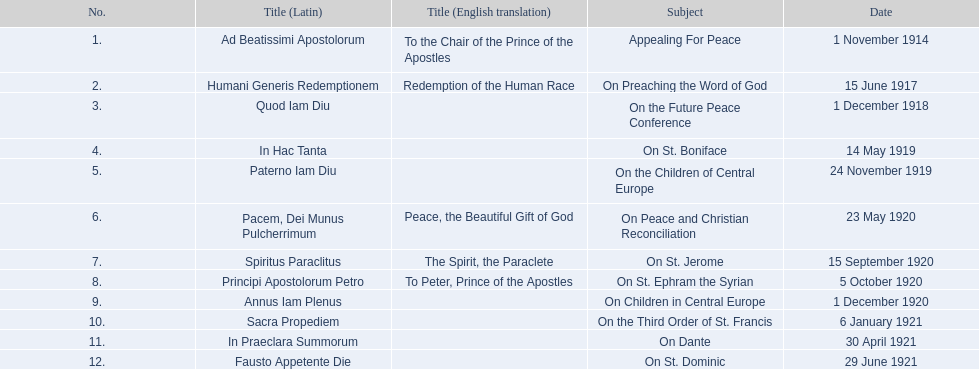Give me the full table as a dictionary. {'header': ['No.', 'Title (Latin)', 'Title (English translation)', 'Subject', 'Date'], 'rows': [['1.', 'Ad Beatissimi Apostolorum', 'To the Chair of the Prince of the Apostles', 'Appealing For Peace', '1 November 1914'], ['2.', 'Humani Generis Redemptionem', 'Redemption of the Human Race', 'On Preaching the Word of God', '15 June 1917'], ['3.', 'Quod Iam Diu', '', 'On the Future Peace Conference', '1 December 1918'], ['4.', 'In Hac Tanta', '', 'On St. Boniface', '14 May 1919'], ['5.', 'Paterno Iam Diu', '', 'On the Children of Central Europe', '24 November 1919'], ['6.', 'Pacem, Dei Munus Pulcherrimum', 'Peace, the Beautiful Gift of God', 'On Peace and Christian Reconciliation', '23 May 1920'], ['7.', 'Spiritus Paraclitus', 'The Spirit, the Paraclete', 'On St. Jerome', '15 September 1920'], ['8.', 'Principi Apostolorum Petro', 'To Peter, Prince of the Apostles', 'On St. Ephram the Syrian', '5 October 1920'], ['9.', 'Annus Iam Plenus', '', 'On Children in Central Europe', '1 December 1920'], ['10.', 'Sacra Propediem', '', 'On the Third Order of St. Francis', '6 January 1921'], ['11.', 'In Praeclara Summorum', '', 'On Dante', '30 April 1921'], ['12.', 'Fausto Appetente Die', '', 'On St. Dominic', '29 June 1921']]} What are the chronological order of pope benedict xv's encyclicals? 1 November 1914, 15 June 1917, 1 December 1918, 14 May 1919, 24 November 1919, 23 May 1920, 15 September 1920, 5 October 1920, 1 December 1920, 6 January 1921, 30 April 1921, 29 June 1921. Within these periods, which subject matter was covered on 23 may 1920? On Peace and Christian Reconciliation. 